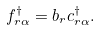Convert formula to latex. <formula><loc_0><loc_0><loc_500><loc_500>f _ { r \alpha } ^ { \dag } = b _ { r } c _ { r \alpha } ^ { \dag } .</formula> 